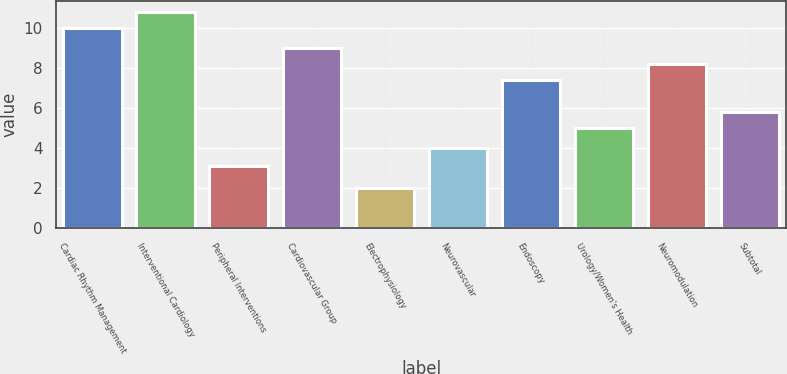Convert chart to OTSL. <chart><loc_0><loc_0><loc_500><loc_500><bar_chart><fcel>Cardiac Rhythm Management<fcel>Interventional Cardiology<fcel>Peripheral Interventions<fcel>Cardiovascular Group<fcel>Electrophysiology<fcel>Neurovascular<fcel>Endoscopy<fcel>Urology/Women's Health<fcel>Neuromodulation<fcel>Subtotal<nl><fcel>10<fcel>10.8<fcel>3.08<fcel>9<fcel>2<fcel>4<fcel>7.4<fcel>5<fcel>8.2<fcel>5.8<nl></chart> 